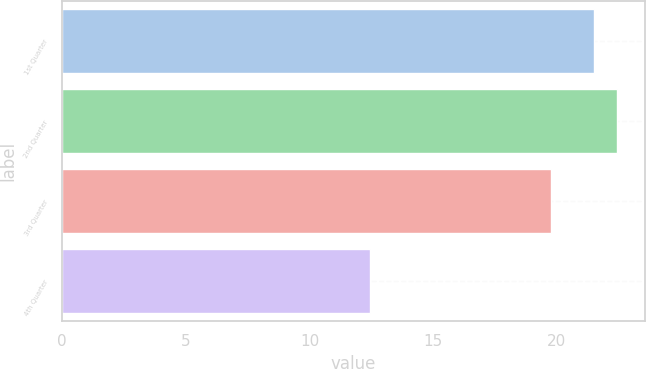<chart> <loc_0><loc_0><loc_500><loc_500><bar_chart><fcel>1st Quarter<fcel>2nd Quarter<fcel>3rd Quarter<fcel>4th Quarter<nl><fcel>21.51<fcel>22.44<fcel>19.76<fcel>12.46<nl></chart> 